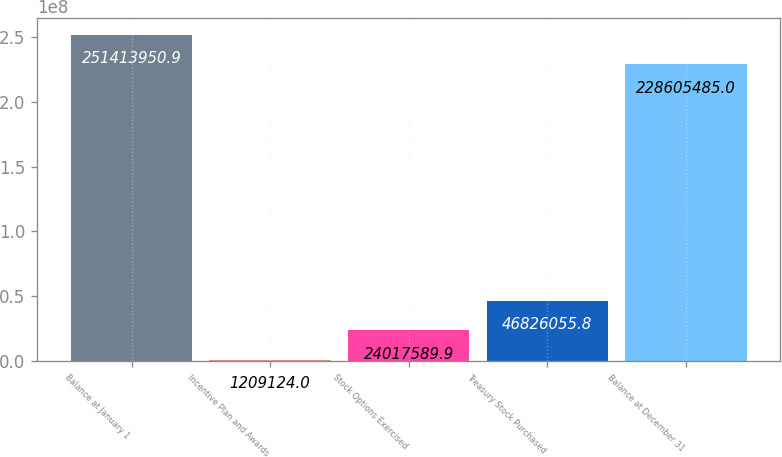Convert chart to OTSL. <chart><loc_0><loc_0><loc_500><loc_500><bar_chart><fcel>Balance at January 1<fcel>Incentive Plan and Awards<fcel>Stock Options Exercised<fcel>Treasury Stock Purchased<fcel>Balance at December 31<nl><fcel>2.51414e+08<fcel>1.20912e+06<fcel>2.40176e+07<fcel>4.68261e+07<fcel>2.28605e+08<nl></chart> 